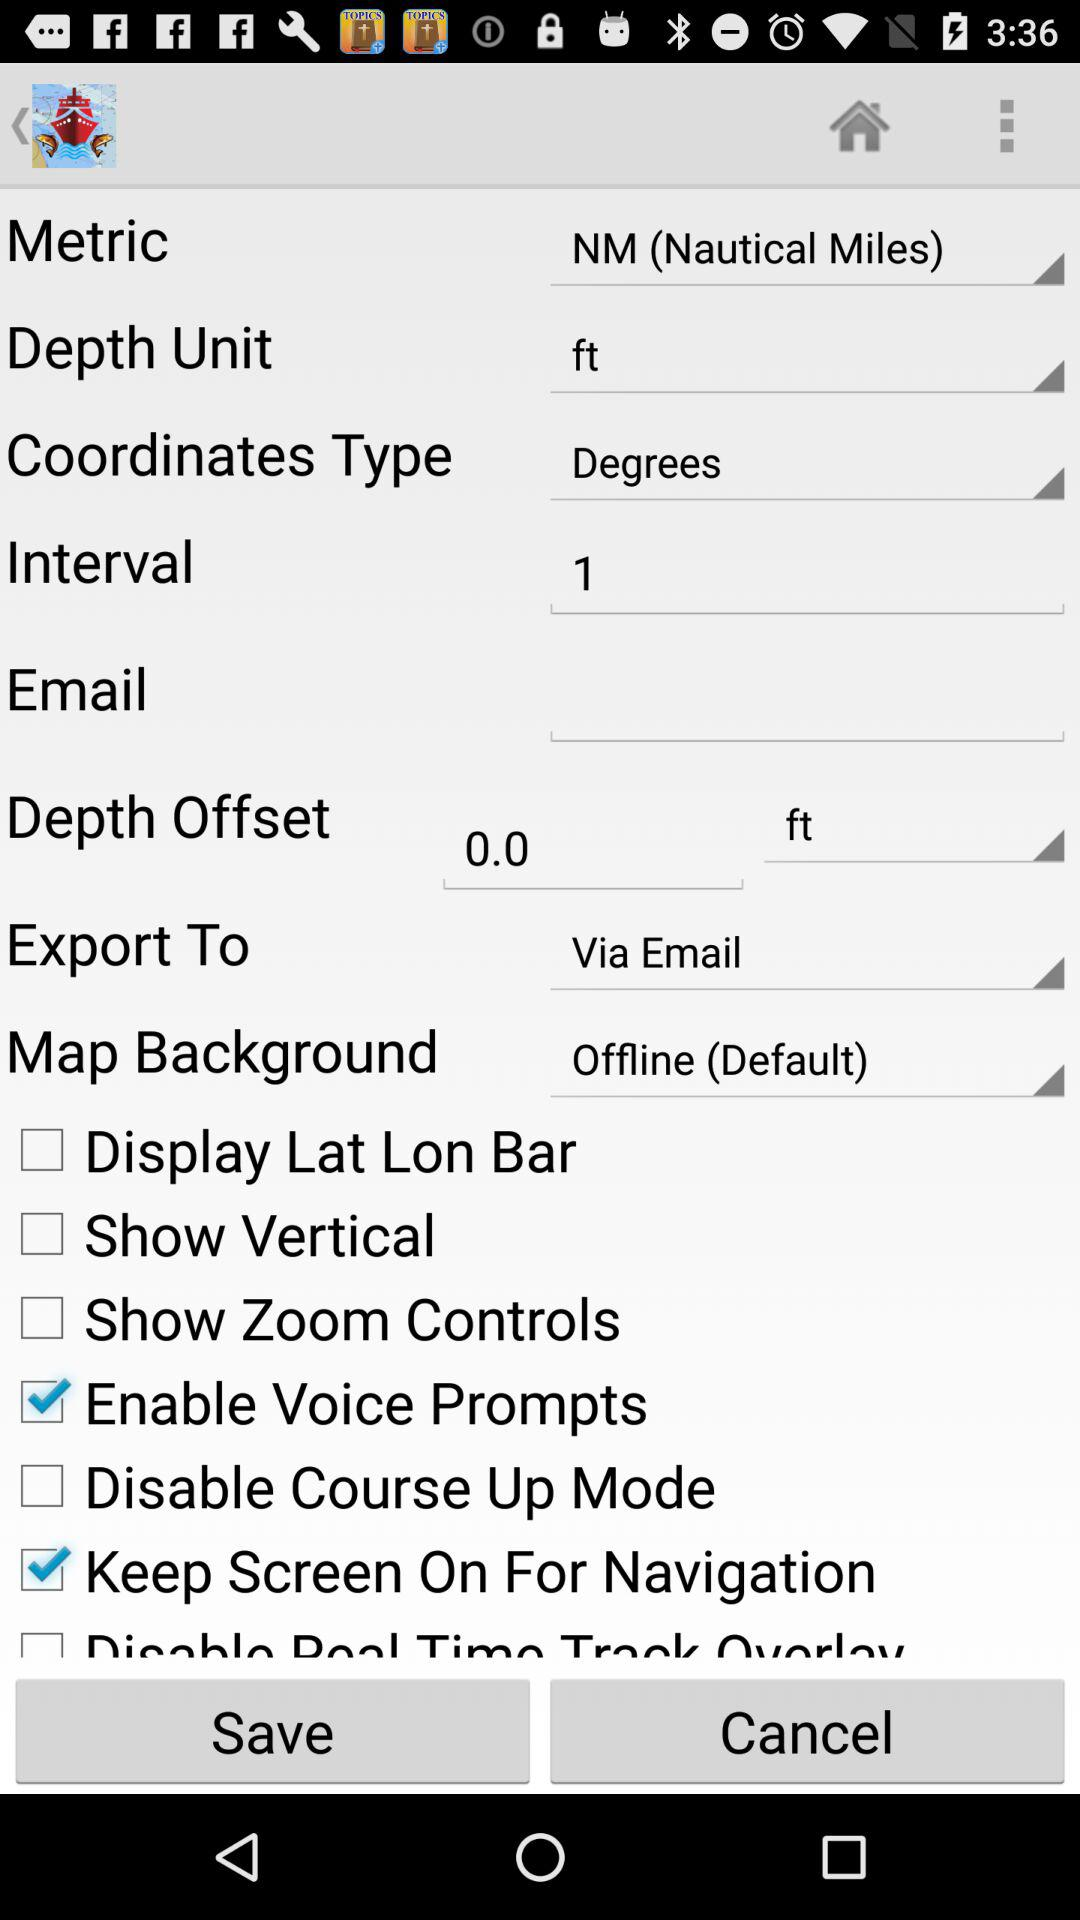What is the status of the "Show Vertical"? The status is "off". 